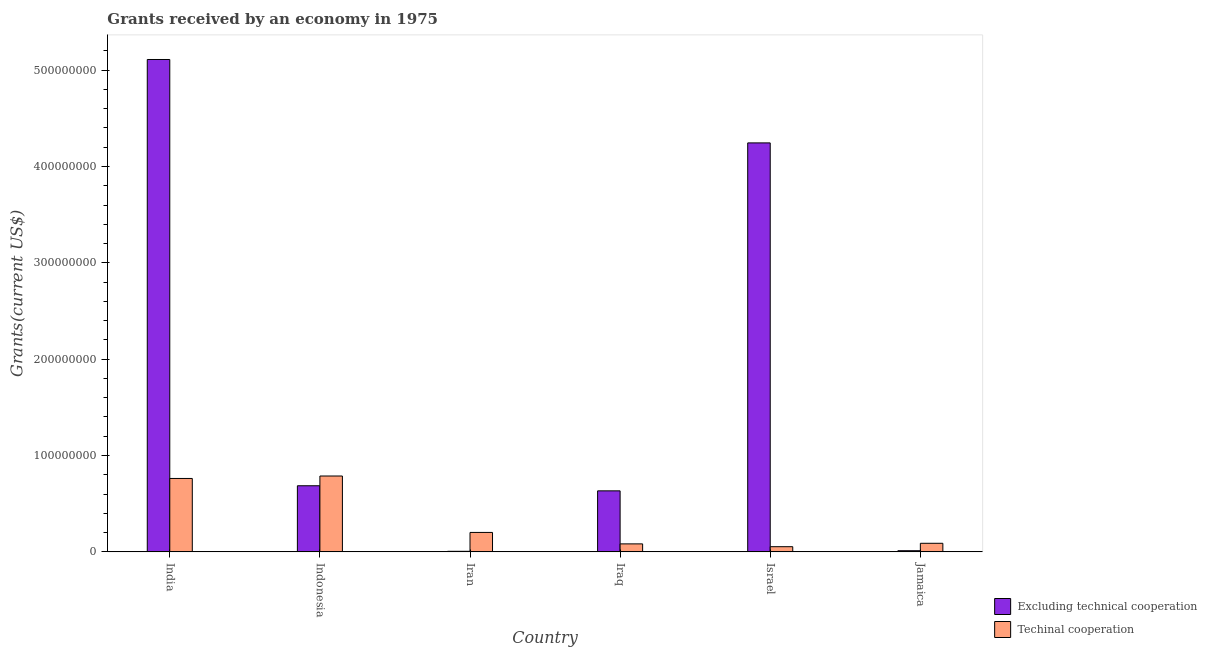How many groups of bars are there?
Your answer should be very brief. 6. What is the amount of grants received(excluding technical cooperation) in Iraq?
Your response must be concise. 6.33e+07. Across all countries, what is the maximum amount of grants received(including technical cooperation)?
Your answer should be very brief. 7.87e+07. Across all countries, what is the minimum amount of grants received(including technical cooperation)?
Your answer should be very brief. 5.37e+06. In which country was the amount of grants received(excluding technical cooperation) maximum?
Your answer should be compact. India. In which country was the amount of grants received(excluding technical cooperation) minimum?
Keep it short and to the point. Iran. What is the total amount of grants received(including technical cooperation) in the graph?
Make the answer very short. 1.98e+08. What is the difference between the amount of grants received(including technical cooperation) in Indonesia and that in Jamaica?
Give a very brief answer. 6.98e+07. What is the difference between the amount of grants received(excluding technical cooperation) in Iran and the amount of grants received(including technical cooperation) in India?
Keep it short and to the point. -7.56e+07. What is the average amount of grants received(including technical cooperation) per country?
Your answer should be very brief. 3.29e+07. What is the difference between the amount of grants received(including technical cooperation) and amount of grants received(excluding technical cooperation) in Iran?
Give a very brief answer. 1.96e+07. What is the ratio of the amount of grants received(including technical cooperation) in India to that in Iraq?
Provide a short and direct response. 9.19. Is the amount of grants received(excluding technical cooperation) in Israel less than that in Jamaica?
Give a very brief answer. No. What is the difference between the highest and the second highest amount of grants received(including technical cooperation)?
Your response must be concise. 2.55e+06. What is the difference between the highest and the lowest amount of grants received(including technical cooperation)?
Provide a succinct answer. 7.34e+07. In how many countries, is the amount of grants received(including technical cooperation) greater than the average amount of grants received(including technical cooperation) taken over all countries?
Your response must be concise. 2. Is the sum of the amount of grants received(excluding technical cooperation) in Indonesia and Iraq greater than the maximum amount of grants received(including technical cooperation) across all countries?
Provide a succinct answer. Yes. What does the 2nd bar from the left in Israel represents?
Your answer should be compact. Techinal cooperation. What does the 1st bar from the right in Jamaica represents?
Keep it short and to the point. Techinal cooperation. Are all the bars in the graph horizontal?
Provide a succinct answer. No. Where does the legend appear in the graph?
Keep it short and to the point. Bottom right. How are the legend labels stacked?
Make the answer very short. Vertical. What is the title of the graph?
Your answer should be very brief. Grants received by an economy in 1975. What is the label or title of the X-axis?
Provide a short and direct response. Country. What is the label or title of the Y-axis?
Give a very brief answer. Grants(current US$). What is the Grants(current US$) in Excluding technical cooperation in India?
Give a very brief answer. 5.11e+08. What is the Grants(current US$) of Techinal cooperation in India?
Provide a short and direct response. 7.62e+07. What is the Grants(current US$) in Excluding technical cooperation in Indonesia?
Keep it short and to the point. 6.86e+07. What is the Grants(current US$) of Techinal cooperation in Indonesia?
Give a very brief answer. 7.87e+07. What is the Grants(current US$) in Excluding technical cooperation in Iran?
Your answer should be compact. 5.90e+05. What is the Grants(current US$) of Techinal cooperation in Iran?
Make the answer very short. 2.02e+07. What is the Grants(current US$) in Excluding technical cooperation in Iraq?
Your answer should be compact. 6.33e+07. What is the Grants(current US$) of Techinal cooperation in Iraq?
Give a very brief answer. 8.29e+06. What is the Grants(current US$) of Excluding technical cooperation in Israel?
Offer a very short reply. 4.24e+08. What is the Grants(current US$) in Techinal cooperation in Israel?
Provide a succinct answer. 5.37e+06. What is the Grants(current US$) of Excluding technical cooperation in Jamaica?
Make the answer very short. 1.20e+06. What is the Grants(current US$) of Techinal cooperation in Jamaica?
Give a very brief answer. 8.91e+06. Across all countries, what is the maximum Grants(current US$) in Excluding technical cooperation?
Your response must be concise. 5.11e+08. Across all countries, what is the maximum Grants(current US$) of Techinal cooperation?
Offer a very short reply. 7.87e+07. Across all countries, what is the minimum Grants(current US$) in Excluding technical cooperation?
Your response must be concise. 5.90e+05. Across all countries, what is the minimum Grants(current US$) in Techinal cooperation?
Your answer should be compact. 5.37e+06. What is the total Grants(current US$) of Excluding technical cooperation in the graph?
Give a very brief answer. 1.07e+09. What is the total Grants(current US$) in Techinal cooperation in the graph?
Offer a very short reply. 1.98e+08. What is the difference between the Grants(current US$) in Excluding technical cooperation in India and that in Indonesia?
Offer a very short reply. 4.42e+08. What is the difference between the Grants(current US$) in Techinal cooperation in India and that in Indonesia?
Ensure brevity in your answer.  -2.55e+06. What is the difference between the Grants(current US$) in Excluding technical cooperation in India and that in Iran?
Provide a succinct answer. 5.10e+08. What is the difference between the Grants(current US$) in Techinal cooperation in India and that in Iran?
Make the answer very short. 5.60e+07. What is the difference between the Grants(current US$) in Excluding technical cooperation in India and that in Iraq?
Your response must be concise. 4.48e+08. What is the difference between the Grants(current US$) of Techinal cooperation in India and that in Iraq?
Provide a succinct answer. 6.79e+07. What is the difference between the Grants(current US$) of Excluding technical cooperation in India and that in Israel?
Ensure brevity in your answer.  8.66e+07. What is the difference between the Grants(current US$) of Techinal cooperation in India and that in Israel?
Your response must be concise. 7.08e+07. What is the difference between the Grants(current US$) of Excluding technical cooperation in India and that in Jamaica?
Make the answer very short. 5.10e+08. What is the difference between the Grants(current US$) in Techinal cooperation in India and that in Jamaica?
Provide a succinct answer. 6.73e+07. What is the difference between the Grants(current US$) of Excluding technical cooperation in Indonesia and that in Iran?
Keep it short and to the point. 6.80e+07. What is the difference between the Grants(current US$) in Techinal cooperation in Indonesia and that in Iran?
Give a very brief answer. 5.86e+07. What is the difference between the Grants(current US$) in Excluding technical cooperation in Indonesia and that in Iraq?
Ensure brevity in your answer.  5.29e+06. What is the difference between the Grants(current US$) of Techinal cooperation in Indonesia and that in Iraq?
Your response must be concise. 7.04e+07. What is the difference between the Grants(current US$) of Excluding technical cooperation in Indonesia and that in Israel?
Your answer should be very brief. -3.56e+08. What is the difference between the Grants(current US$) in Techinal cooperation in Indonesia and that in Israel?
Ensure brevity in your answer.  7.34e+07. What is the difference between the Grants(current US$) of Excluding technical cooperation in Indonesia and that in Jamaica?
Offer a terse response. 6.74e+07. What is the difference between the Grants(current US$) of Techinal cooperation in Indonesia and that in Jamaica?
Offer a terse response. 6.98e+07. What is the difference between the Grants(current US$) in Excluding technical cooperation in Iran and that in Iraq?
Your answer should be compact. -6.28e+07. What is the difference between the Grants(current US$) of Techinal cooperation in Iran and that in Iraq?
Your response must be concise. 1.19e+07. What is the difference between the Grants(current US$) of Excluding technical cooperation in Iran and that in Israel?
Make the answer very short. -4.24e+08. What is the difference between the Grants(current US$) in Techinal cooperation in Iran and that in Israel?
Offer a very short reply. 1.48e+07. What is the difference between the Grants(current US$) in Excluding technical cooperation in Iran and that in Jamaica?
Your answer should be very brief. -6.10e+05. What is the difference between the Grants(current US$) in Techinal cooperation in Iran and that in Jamaica?
Keep it short and to the point. 1.13e+07. What is the difference between the Grants(current US$) of Excluding technical cooperation in Iraq and that in Israel?
Make the answer very short. -3.61e+08. What is the difference between the Grants(current US$) of Techinal cooperation in Iraq and that in Israel?
Ensure brevity in your answer.  2.92e+06. What is the difference between the Grants(current US$) in Excluding technical cooperation in Iraq and that in Jamaica?
Keep it short and to the point. 6.21e+07. What is the difference between the Grants(current US$) of Techinal cooperation in Iraq and that in Jamaica?
Offer a terse response. -6.20e+05. What is the difference between the Grants(current US$) in Excluding technical cooperation in Israel and that in Jamaica?
Your answer should be compact. 4.23e+08. What is the difference between the Grants(current US$) in Techinal cooperation in Israel and that in Jamaica?
Offer a terse response. -3.54e+06. What is the difference between the Grants(current US$) in Excluding technical cooperation in India and the Grants(current US$) in Techinal cooperation in Indonesia?
Make the answer very short. 4.32e+08. What is the difference between the Grants(current US$) in Excluding technical cooperation in India and the Grants(current US$) in Techinal cooperation in Iran?
Give a very brief answer. 4.91e+08. What is the difference between the Grants(current US$) of Excluding technical cooperation in India and the Grants(current US$) of Techinal cooperation in Iraq?
Provide a succinct answer. 5.03e+08. What is the difference between the Grants(current US$) in Excluding technical cooperation in India and the Grants(current US$) in Techinal cooperation in Israel?
Make the answer very short. 5.06e+08. What is the difference between the Grants(current US$) of Excluding technical cooperation in India and the Grants(current US$) of Techinal cooperation in Jamaica?
Offer a very short reply. 5.02e+08. What is the difference between the Grants(current US$) in Excluding technical cooperation in Indonesia and the Grants(current US$) in Techinal cooperation in Iran?
Give a very brief answer. 4.84e+07. What is the difference between the Grants(current US$) in Excluding technical cooperation in Indonesia and the Grants(current US$) in Techinal cooperation in Iraq?
Offer a terse response. 6.03e+07. What is the difference between the Grants(current US$) of Excluding technical cooperation in Indonesia and the Grants(current US$) of Techinal cooperation in Israel?
Your answer should be very brief. 6.33e+07. What is the difference between the Grants(current US$) in Excluding technical cooperation in Indonesia and the Grants(current US$) in Techinal cooperation in Jamaica?
Provide a succinct answer. 5.97e+07. What is the difference between the Grants(current US$) in Excluding technical cooperation in Iran and the Grants(current US$) in Techinal cooperation in Iraq?
Your answer should be compact. -7.70e+06. What is the difference between the Grants(current US$) of Excluding technical cooperation in Iran and the Grants(current US$) of Techinal cooperation in Israel?
Give a very brief answer. -4.78e+06. What is the difference between the Grants(current US$) of Excluding technical cooperation in Iran and the Grants(current US$) of Techinal cooperation in Jamaica?
Ensure brevity in your answer.  -8.32e+06. What is the difference between the Grants(current US$) in Excluding technical cooperation in Iraq and the Grants(current US$) in Techinal cooperation in Israel?
Your response must be concise. 5.80e+07. What is the difference between the Grants(current US$) in Excluding technical cooperation in Iraq and the Grants(current US$) in Techinal cooperation in Jamaica?
Keep it short and to the point. 5.44e+07. What is the difference between the Grants(current US$) in Excluding technical cooperation in Israel and the Grants(current US$) in Techinal cooperation in Jamaica?
Your answer should be compact. 4.16e+08. What is the average Grants(current US$) in Excluding technical cooperation per country?
Offer a terse response. 1.78e+08. What is the average Grants(current US$) of Techinal cooperation per country?
Ensure brevity in your answer.  3.29e+07. What is the difference between the Grants(current US$) in Excluding technical cooperation and Grants(current US$) in Techinal cooperation in India?
Offer a terse response. 4.35e+08. What is the difference between the Grants(current US$) in Excluding technical cooperation and Grants(current US$) in Techinal cooperation in Indonesia?
Make the answer very short. -1.01e+07. What is the difference between the Grants(current US$) in Excluding technical cooperation and Grants(current US$) in Techinal cooperation in Iran?
Keep it short and to the point. -1.96e+07. What is the difference between the Grants(current US$) in Excluding technical cooperation and Grants(current US$) in Techinal cooperation in Iraq?
Make the answer very short. 5.50e+07. What is the difference between the Grants(current US$) of Excluding technical cooperation and Grants(current US$) of Techinal cooperation in Israel?
Your answer should be very brief. 4.19e+08. What is the difference between the Grants(current US$) in Excluding technical cooperation and Grants(current US$) in Techinal cooperation in Jamaica?
Provide a short and direct response. -7.71e+06. What is the ratio of the Grants(current US$) of Excluding technical cooperation in India to that in Indonesia?
Provide a succinct answer. 7.45. What is the ratio of the Grants(current US$) of Techinal cooperation in India to that in Indonesia?
Your answer should be compact. 0.97. What is the ratio of the Grants(current US$) of Excluding technical cooperation in India to that in Iran?
Offer a terse response. 866.19. What is the ratio of the Grants(current US$) in Techinal cooperation in India to that in Iran?
Your response must be concise. 3.77. What is the ratio of the Grants(current US$) of Excluding technical cooperation in India to that in Iraq?
Offer a terse response. 8.07. What is the ratio of the Grants(current US$) of Techinal cooperation in India to that in Iraq?
Offer a very short reply. 9.19. What is the ratio of the Grants(current US$) of Excluding technical cooperation in India to that in Israel?
Ensure brevity in your answer.  1.2. What is the ratio of the Grants(current US$) in Techinal cooperation in India to that in Israel?
Your response must be concise. 14.19. What is the ratio of the Grants(current US$) of Excluding technical cooperation in India to that in Jamaica?
Offer a very short reply. 425.88. What is the ratio of the Grants(current US$) of Techinal cooperation in India to that in Jamaica?
Your answer should be very brief. 8.55. What is the ratio of the Grants(current US$) of Excluding technical cooperation in Indonesia to that in Iran?
Ensure brevity in your answer.  116.32. What is the ratio of the Grants(current US$) in Techinal cooperation in Indonesia to that in Iran?
Your response must be concise. 3.9. What is the ratio of the Grants(current US$) of Excluding technical cooperation in Indonesia to that in Iraq?
Give a very brief answer. 1.08. What is the ratio of the Grants(current US$) of Techinal cooperation in Indonesia to that in Iraq?
Offer a terse response. 9.5. What is the ratio of the Grants(current US$) of Excluding technical cooperation in Indonesia to that in Israel?
Give a very brief answer. 0.16. What is the ratio of the Grants(current US$) of Techinal cooperation in Indonesia to that in Israel?
Your answer should be compact. 14.66. What is the ratio of the Grants(current US$) in Excluding technical cooperation in Indonesia to that in Jamaica?
Provide a short and direct response. 57.19. What is the ratio of the Grants(current US$) in Techinal cooperation in Indonesia to that in Jamaica?
Offer a very short reply. 8.84. What is the ratio of the Grants(current US$) of Excluding technical cooperation in Iran to that in Iraq?
Provide a short and direct response. 0.01. What is the ratio of the Grants(current US$) of Techinal cooperation in Iran to that in Iraq?
Provide a succinct answer. 2.44. What is the ratio of the Grants(current US$) of Excluding technical cooperation in Iran to that in Israel?
Offer a terse response. 0. What is the ratio of the Grants(current US$) of Techinal cooperation in Iran to that in Israel?
Give a very brief answer. 3.76. What is the ratio of the Grants(current US$) of Excluding technical cooperation in Iran to that in Jamaica?
Provide a short and direct response. 0.49. What is the ratio of the Grants(current US$) of Techinal cooperation in Iran to that in Jamaica?
Keep it short and to the point. 2.27. What is the ratio of the Grants(current US$) in Excluding technical cooperation in Iraq to that in Israel?
Your response must be concise. 0.15. What is the ratio of the Grants(current US$) in Techinal cooperation in Iraq to that in Israel?
Offer a terse response. 1.54. What is the ratio of the Grants(current US$) of Excluding technical cooperation in Iraq to that in Jamaica?
Ensure brevity in your answer.  52.78. What is the ratio of the Grants(current US$) in Techinal cooperation in Iraq to that in Jamaica?
Offer a terse response. 0.93. What is the ratio of the Grants(current US$) of Excluding technical cooperation in Israel to that in Jamaica?
Your answer should be compact. 353.74. What is the ratio of the Grants(current US$) in Techinal cooperation in Israel to that in Jamaica?
Ensure brevity in your answer.  0.6. What is the difference between the highest and the second highest Grants(current US$) of Excluding technical cooperation?
Keep it short and to the point. 8.66e+07. What is the difference between the highest and the second highest Grants(current US$) in Techinal cooperation?
Your response must be concise. 2.55e+06. What is the difference between the highest and the lowest Grants(current US$) of Excluding technical cooperation?
Offer a terse response. 5.10e+08. What is the difference between the highest and the lowest Grants(current US$) in Techinal cooperation?
Your answer should be very brief. 7.34e+07. 